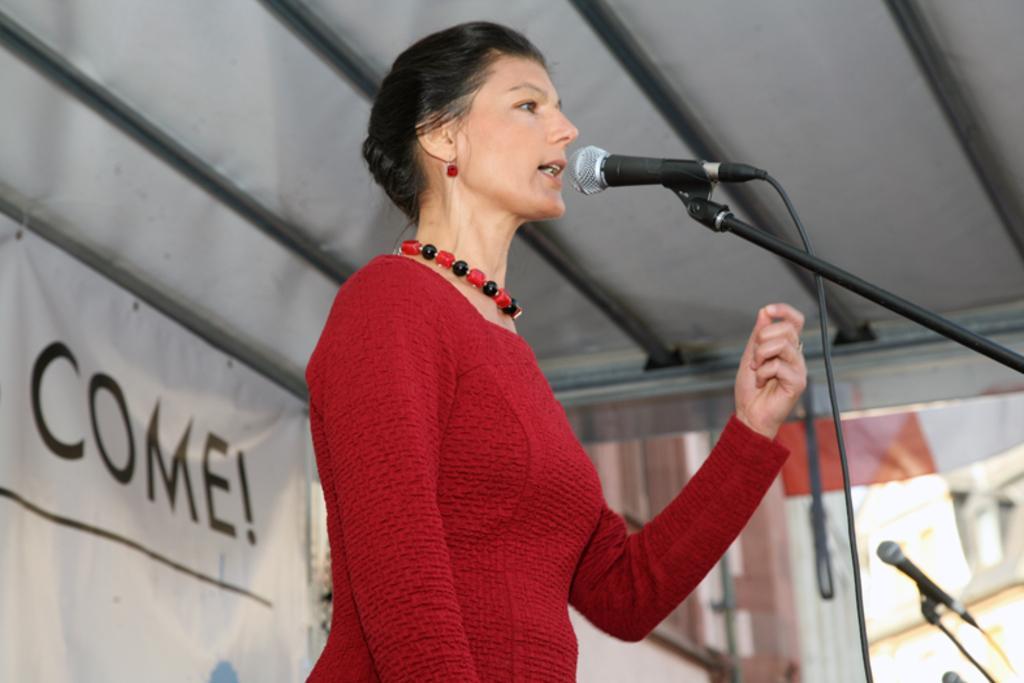Can you describe this image briefly? In this image we can see a lady is talking, there are mice, there is a shed, also we can see a banner with text on it. 